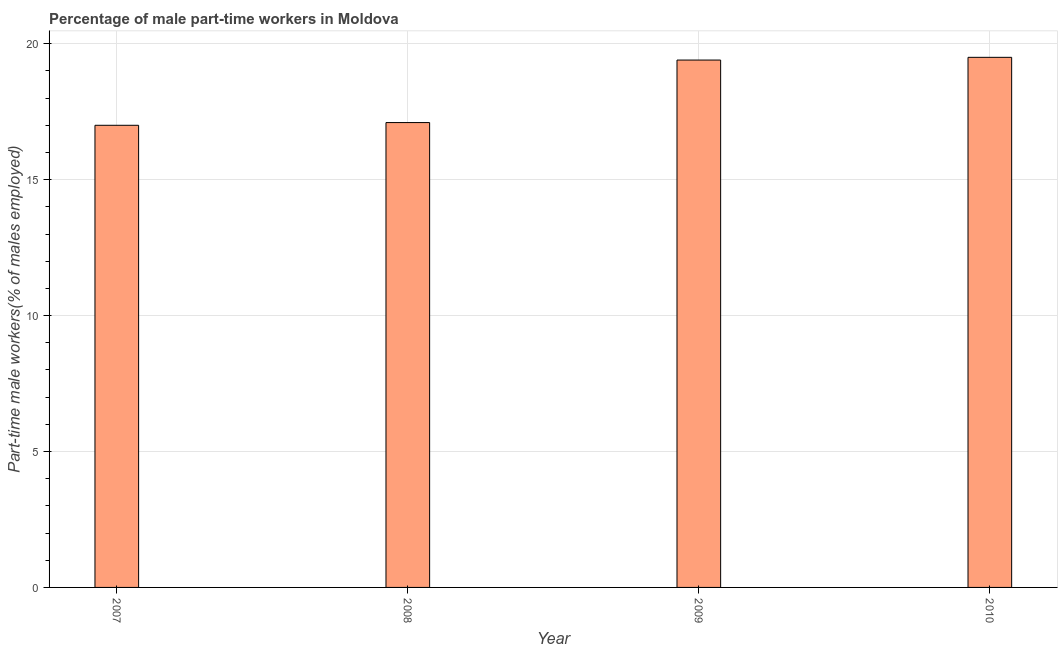What is the title of the graph?
Your answer should be compact. Percentage of male part-time workers in Moldova. What is the label or title of the X-axis?
Keep it short and to the point. Year. What is the label or title of the Y-axis?
Make the answer very short. Part-time male workers(% of males employed). What is the percentage of part-time male workers in 2009?
Your answer should be compact. 19.4. Across all years, what is the minimum percentage of part-time male workers?
Your answer should be very brief. 17. In which year was the percentage of part-time male workers maximum?
Offer a terse response. 2010. In which year was the percentage of part-time male workers minimum?
Provide a succinct answer. 2007. What is the difference between the percentage of part-time male workers in 2008 and 2009?
Ensure brevity in your answer.  -2.3. What is the average percentage of part-time male workers per year?
Keep it short and to the point. 18.25. What is the median percentage of part-time male workers?
Offer a very short reply. 18.25. In how many years, is the percentage of part-time male workers greater than 16 %?
Give a very brief answer. 4. What is the ratio of the percentage of part-time male workers in 2008 to that in 2010?
Ensure brevity in your answer.  0.88. Is the difference between the percentage of part-time male workers in 2008 and 2009 greater than the difference between any two years?
Ensure brevity in your answer.  No. Is the sum of the percentage of part-time male workers in 2007 and 2010 greater than the maximum percentage of part-time male workers across all years?
Give a very brief answer. Yes. How many bars are there?
Your answer should be compact. 4. How many years are there in the graph?
Ensure brevity in your answer.  4. What is the difference between two consecutive major ticks on the Y-axis?
Offer a terse response. 5. What is the Part-time male workers(% of males employed) in 2008?
Keep it short and to the point. 17.1. What is the Part-time male workers(% of males employed) in 2009?
Ensure brevity in your answer.  19.4. What is the Part-time male workers(% of males employed) in 2010?
Offer a terse response. 19.5. What is the difference between the Part-time male workers(% of males employed) in 2007 and 2009?
Your answer should be very brief. -2.4. What is the difference between the Part-time male workers(% of males employed) in 2008 and 2009?
Provide a succinct answer. -2.3. What is the ratio of the Part-time male workers(% of males employed) in 2007 to that in 2009?
Make the answer very short. 0.88. What is the ratio of the Part-time male workers(% of males employed) in 2007 to that in 2010?
Provide a succinct answer. 0.87. What is the ratio of the Part-time male workers(% of males employed) in 2008 to that in 2009?
Your answer should be very brief. 0.88. What is the ratio of the Part-time male workers(% of males employed) in 2008 to that in 2010?
Give a very brief answer. 0.88. 